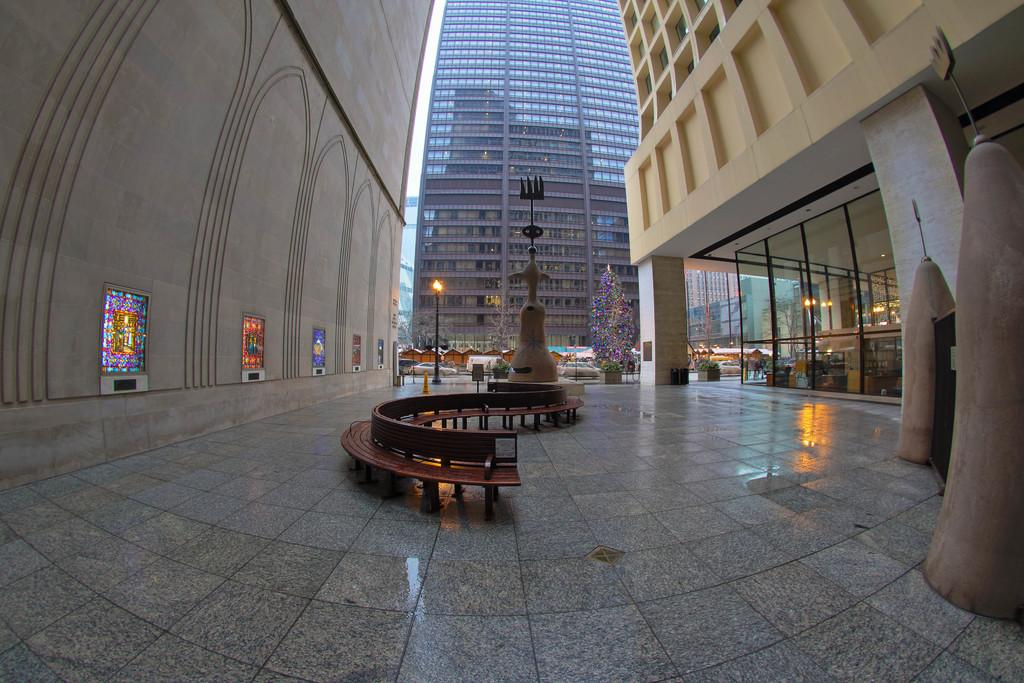What type of seating is visible in the image? There are wooden benches in the image. What is the main object in the center of the image? There is a statue in the image. What provides illumination in the image? There are light poles in the image. What seasonal decoration can be seen in the image? There is a Christmas tree in the image. What type of material is used for the boards in the image? The boards in the image are made of wood. What type of structures are visible in the image? There are buildings in the image. What type of doors are present in the image? There are glass doors in the image. What type of building can be seen in the background of the image? There is a glass building in the background of the image. Who is the creator of the beetle in the image? There is no beetle present in the image, so it is not possible to determine the creator. 